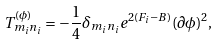Convert formula to latex. <formula><loc_0><loc_0><loc_500><loc_500>T _ { m _ { i } n _ { i } } ^ { ( \phi ) } = - { \frac { 1 } { 4 } } \delta _ { m _ { i } n _ { i } } e ^ { 2 ( F _ { i } - B ) } ( \partial \phi ) ^ { 2 } ,</formula> 